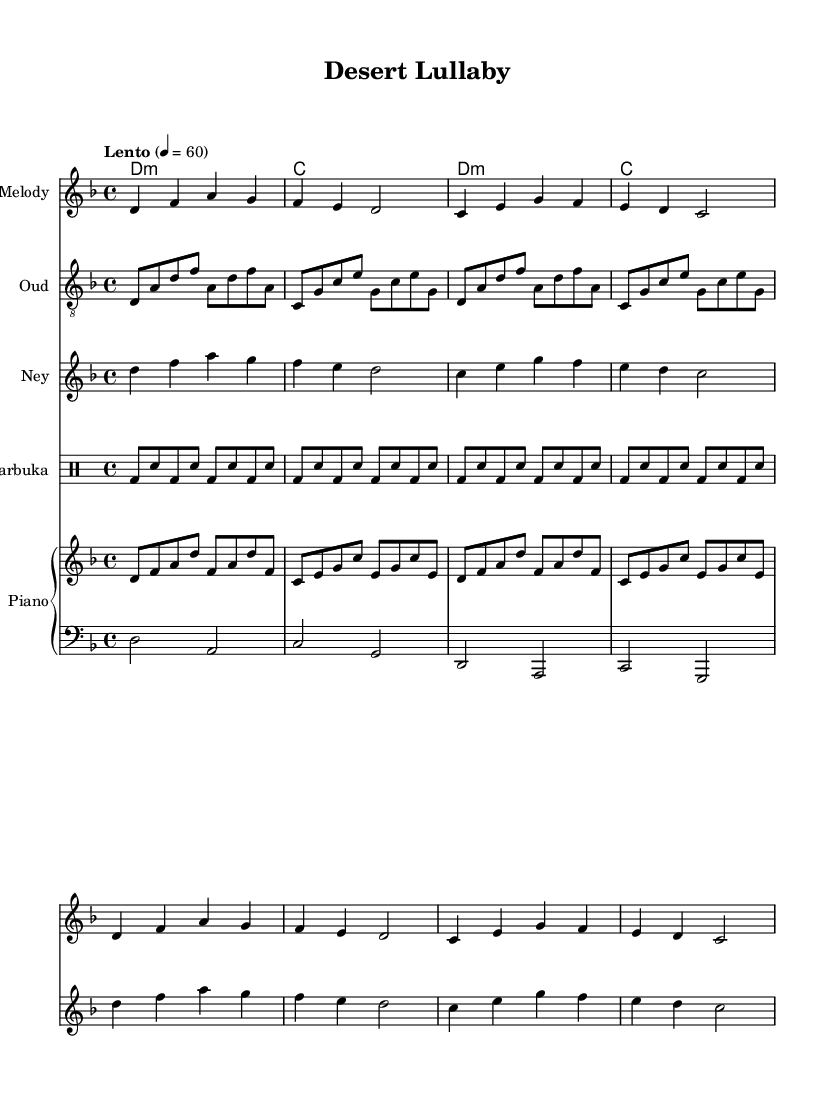What is the key signature of this music? The key signature shows two flats on the staff, indicating that the music is in D minor.
Answer: D minor What is the time signature of this piece? The time signature is indicated at the beginning of the score by the fraction 4/4, meaning there are four beats in each measure.
Answer: 4/4 What is the tempo marking for this piece? The tempo is labeled as "Lento" at the beginning, which indicates a slow pace, typically around 60 beats per minute.
Answer: Lento What type of drum is used in this composition? The sheet music has a dedicated staff labeled "Darbuka," indicating the specific drum used in this piece.
Answer: Darbuka How many measures are in the melody section? By counting the measures outlined in the melody part, there are a total of 8 measures.
Answer: 8 What traditional instrument features a distinctive eight-note pattern in the score? The Oud section is characterized by its rhythmic eight-note patterns written across its respective staff.
Answer: Oud What two instruments play in harmony with the melody? The Oud and Ney sections accompany the melody, providing a fusion of traditional sounds with modern elements.
Answer: Oud and Ney 